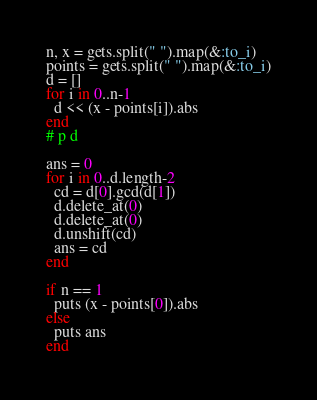Convert code to text. <code><loc_0><loc_0><loc_500><loc_500><_Ruby_>n, x = gets.split(" ").map(&:to_i)
points = gets.split(" ").map(&:to_i)
d = []
for i in 0..n-1
  d << (x - points[i]).abs
end
# p d

ans = 0
for i in 0..d.length-2
  cd = d[0].gcd(d[1])
  d.delete_at(0)
  d.delete_at(0)
  d.unshift(cd)
  ans = cd
end

if n == 1
  puts (x - points[0]).abs
else
  puts ans
end</code> 